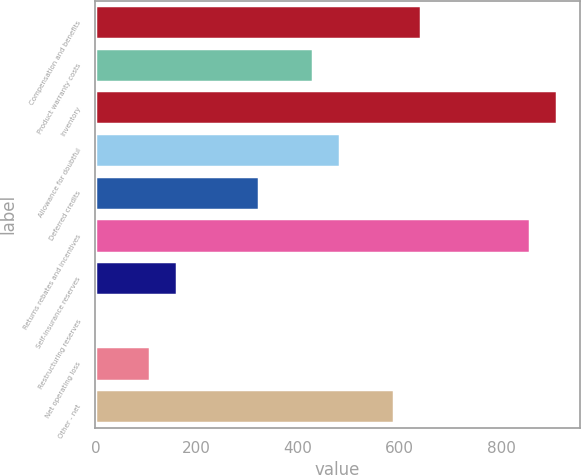Convert chart to OTSL. <chart><loc_0><loc_0><loc_500><loc_500><bar_chart><fcel>Compensation and benefits<fcel>Product warranty costs<fcel>Inventory<fcel>Allowance for doubtful<fcel>Deferred credits<fcel>Returns rebates and incentives<fcel>Self-insurance reserves<fcel>Restructuring reserves<fcel>Net operating loss<fcel>Other - net<nl><fcel>642.74<fcel>428.86<fcel>910.09<fcel>482.33<fcel>321.92<fcel>856.62<fcel>161.51<fcel>1.1<fcel>108.04<fcel>589.27<nl></chart> 